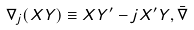Convert formula to latex. <formula><loc_0><loc_0><loc_500><loc_500>\nabla _ { j } ( X Y ) \equiv X Y ^ { \prime } - j X ^ { \prime } Y , \bar { \nabla }</formula> 